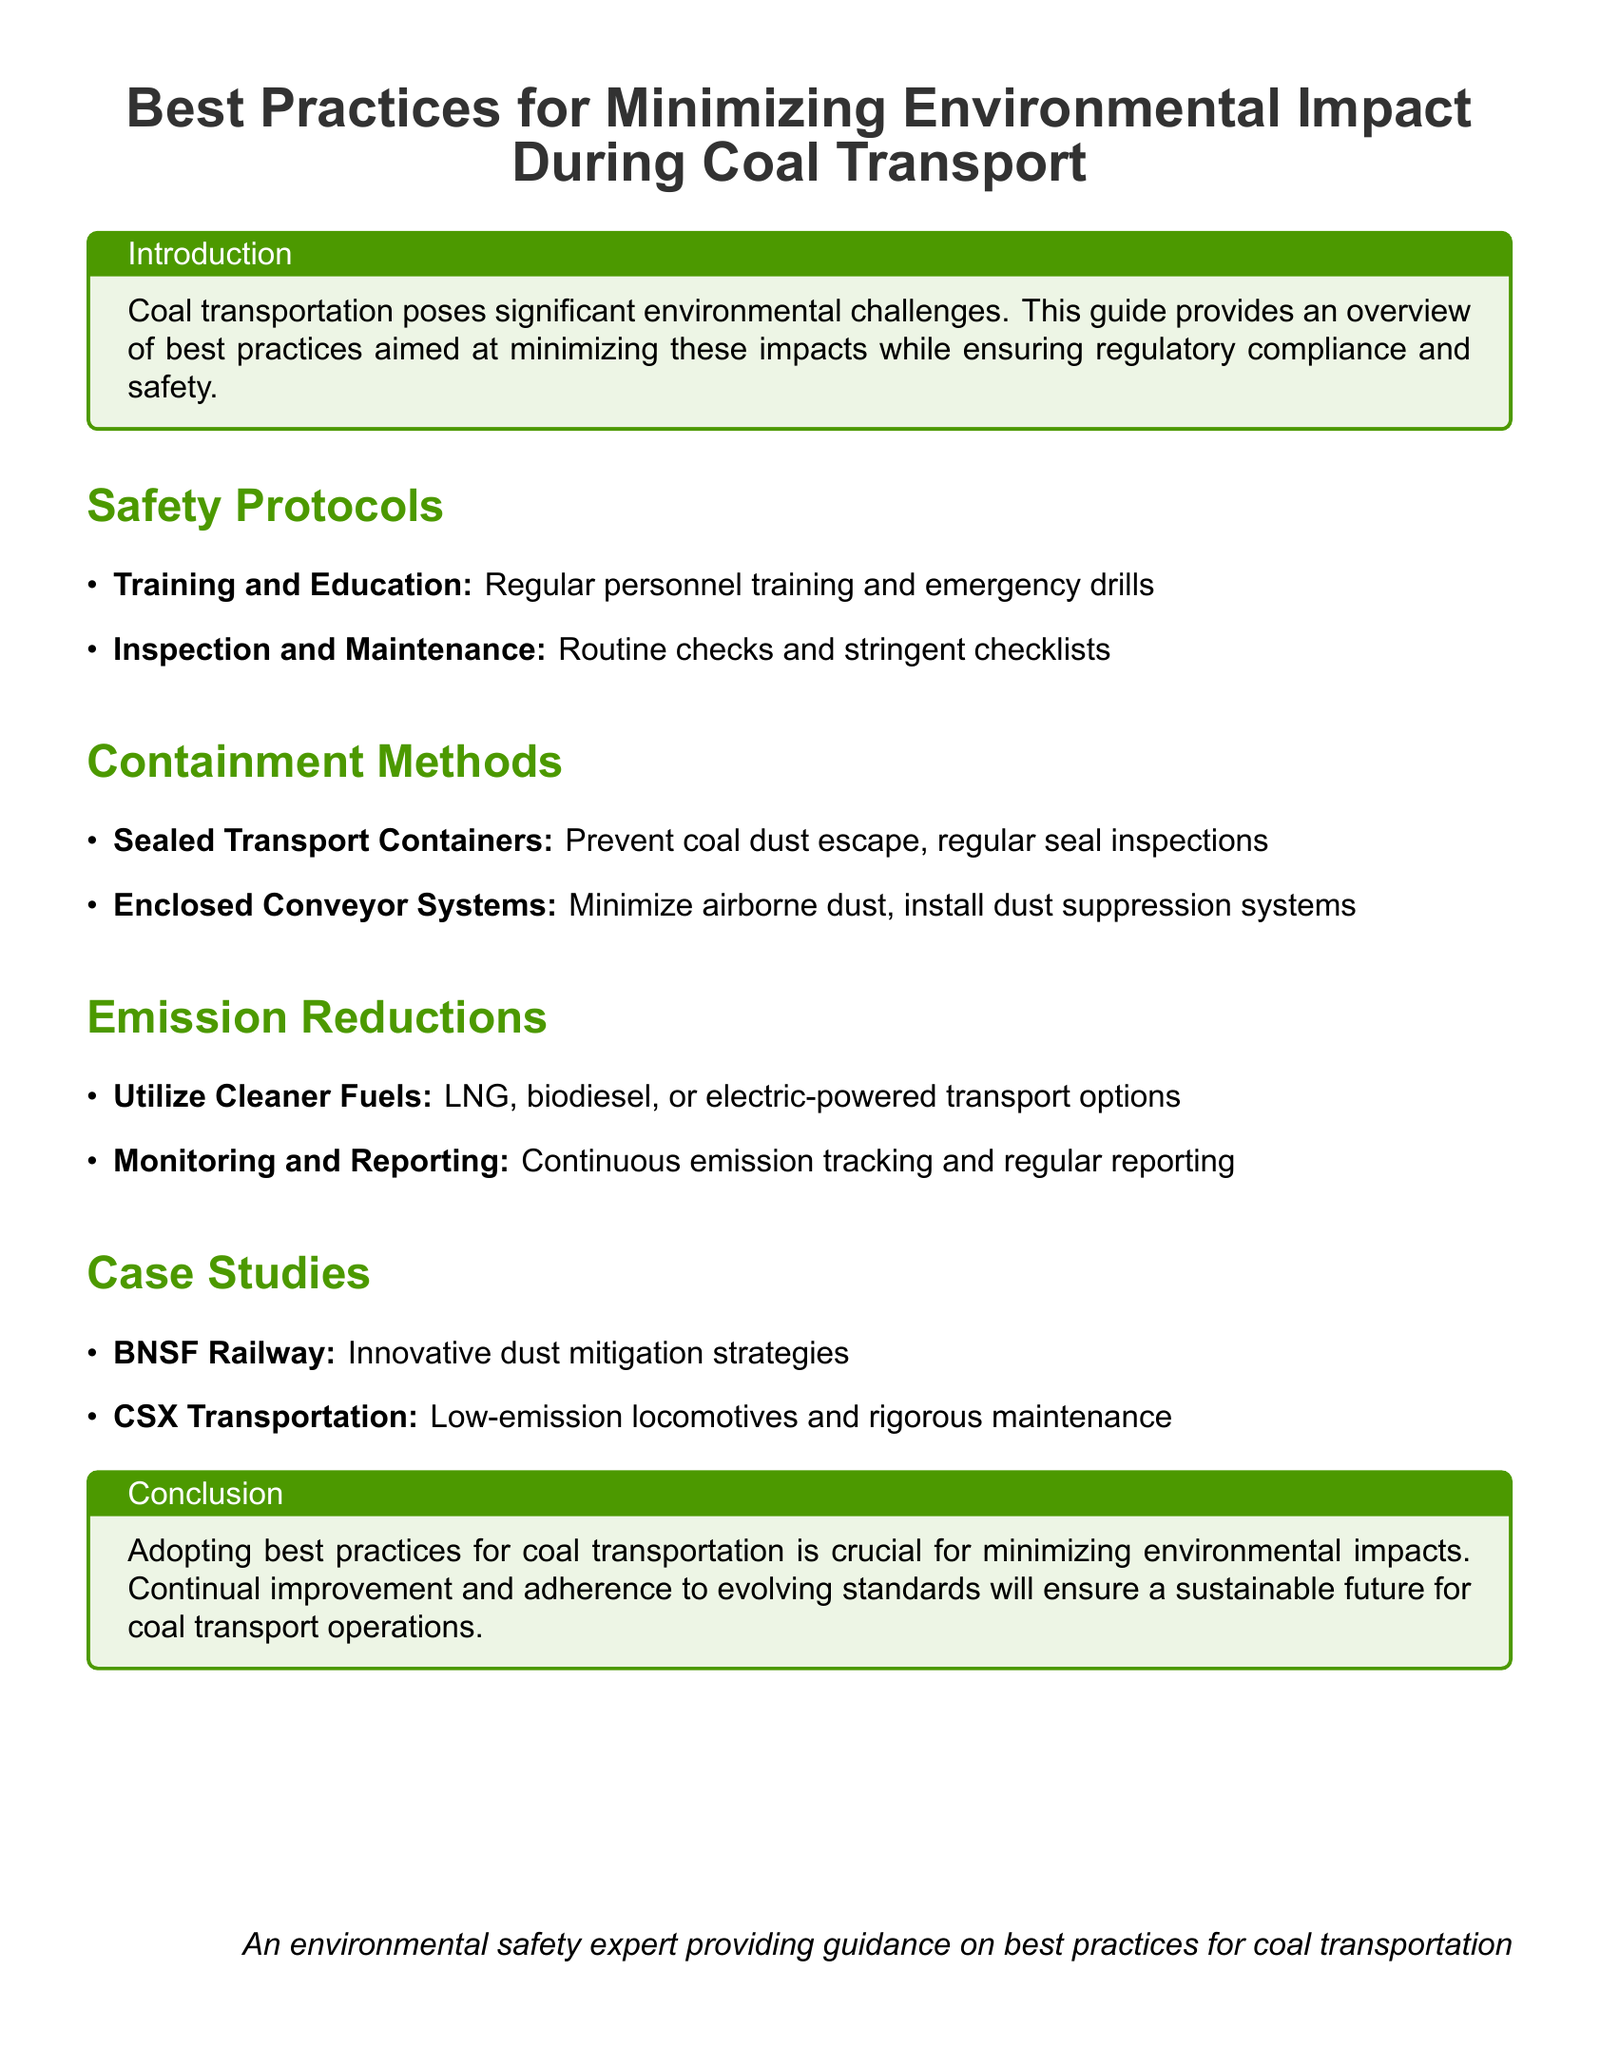What are the two main safety protocols listed? The document lists "Training and Education" and "Inspection and Maintenance" as the two main safety protocols.
Answer: Training and Education, Inspection and Maintenance What is one method of emission reduction mentioned? The document mentions "Utilize Cleaner Fuels" as a method of emission reduction.
Answer: Utilize Cleaner Fuels Which railway company is mentioned for innovative dust mitigation strategies? The case study section highlights "BNSF Railway" for its innovative dust mitigation strategies.
Answer: BNSF Railway What is the title of the document? The document’s title is highlighted in the introduction as "Best Practices for Minimizing Environmental Impact During Coal Transport."
Answer: Best Practices for Minimizing Environmental Impact During Coal Transport What color is used for the section titles? The document uses a color for section titles that is specified as "leafgreen."
Answer: leafgreen What conclusion does the document provide? The conclusion emphasizes that "Adopting best practices for coal transportation is crucial for minimizing environmental impacts."
Answer: Adopting best practices for coal transportation is crucial for minimizing environmental impacts How many case studies are listed in the document? The document lists two case studies regarding coal transport practices.
Answer: Two 